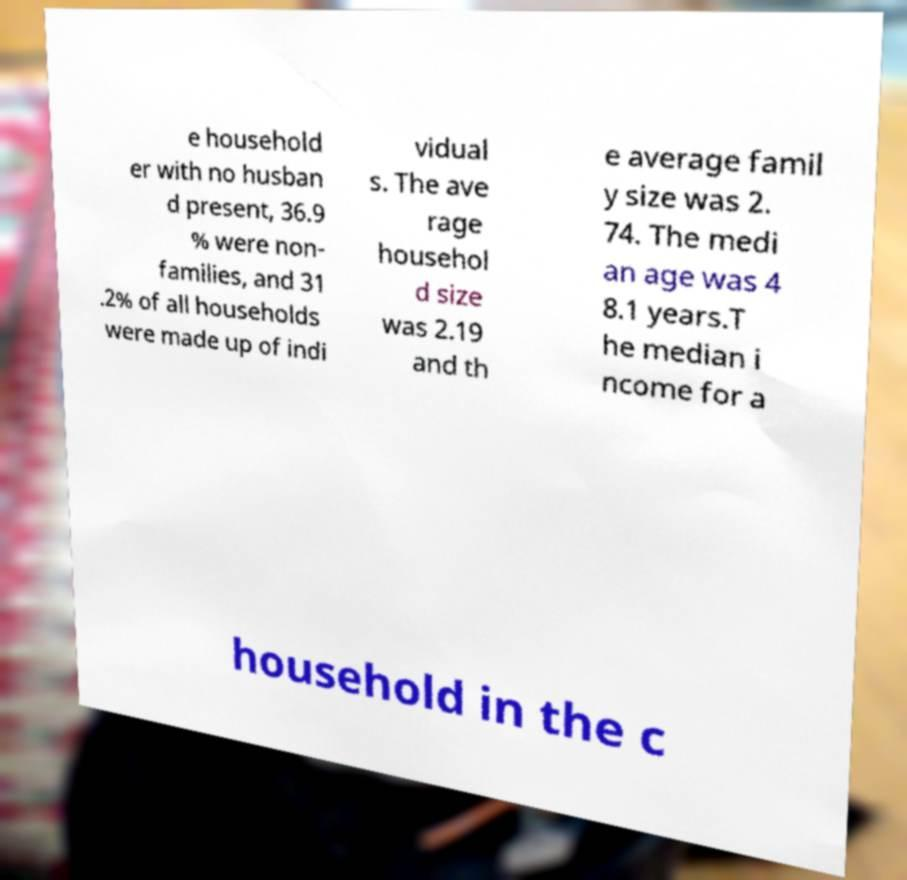Can you read and provide the text displayed in the image?This photo seems to have some interesting text. Can you extract and type it out for me? e household er with no husban d present, 36.9 % were non- families, and 31 .2% of all households were made up of indi vidual s. The ave rage househol d size was 2.19 and th e average famil y size was 2. 74. The medi an age was 4 8.1 years.T he median i ncome for a household in the c 